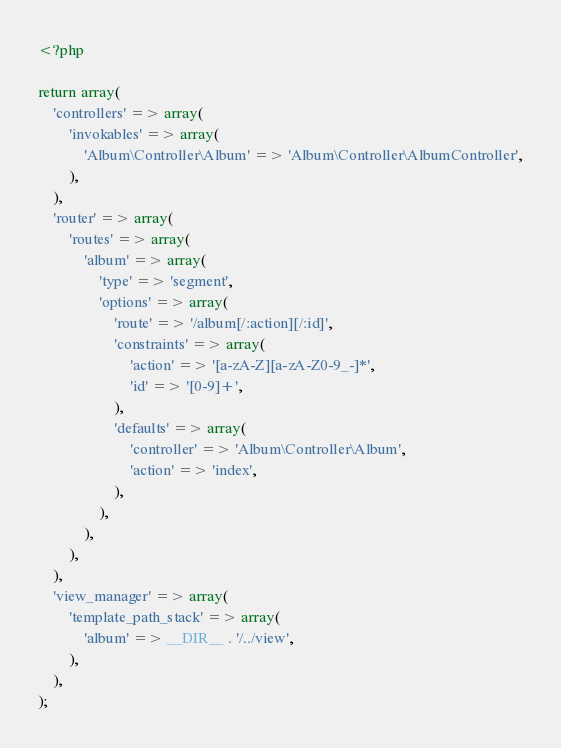Convert code to text. <code><loc_0><loc_0><loc_500><loc_500><_PHP_><?php

return array(
    'controllers' => array(
        'invokables' => array(
            'Album\Controller\Album' => 'Album\Controller\AlbumController',
        ),
    ),
    'router' => array(
        'routes' => array(
            'album' => array(
                'type' => 'segment',
                'options' => array(
                    'route' => '/album[/:action][/:id]',
                    'constraints' => array(
                        'action' => '[a-zA-Z][a-zA-Z0-9_-]*',
                        'id' => '[0-9]+',
                    ),
                    'defaults' => array(
                        'controller' => 'Album\Controller\Album',
                        'action' => 'index',
                    ),
                ),
            ),
        ),
    ),
    'view_manager' => array(
        'template_path_stack' => array(
            'album' => __DIR__ . '/../view',
        ),
    ),
);
</code> 